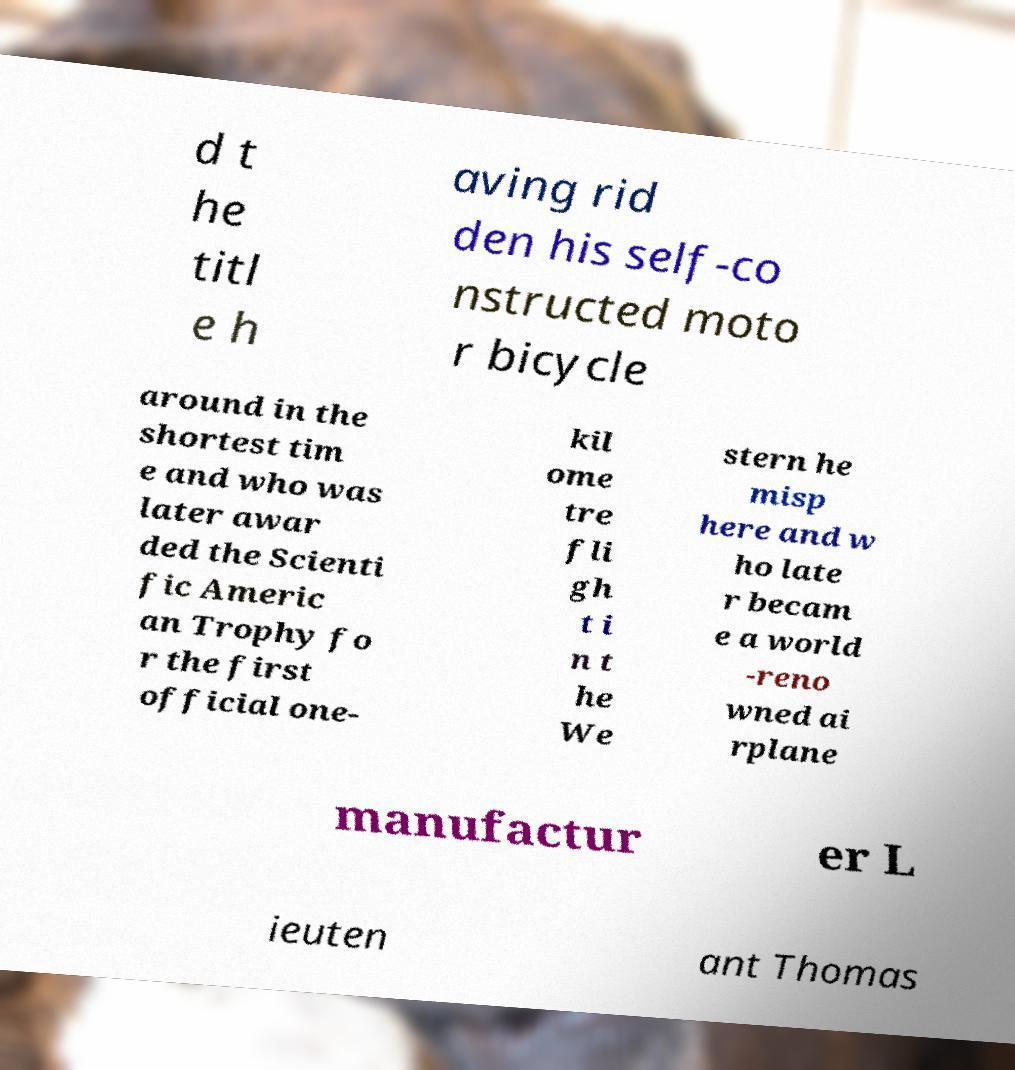Could you extract and type out the text from this image? d t he titl e h aving rid den his self-co nstructed moto r bicycle around in the shortest tim e and who was later awar ded the Scienti fic Americ an Trophy fo r the first official one- kil ome tre fli gh t i n t he We stern he misp here and w ho late r becam e a world -reno wned ai rplane manufactur er L ieuten ant Thomas 